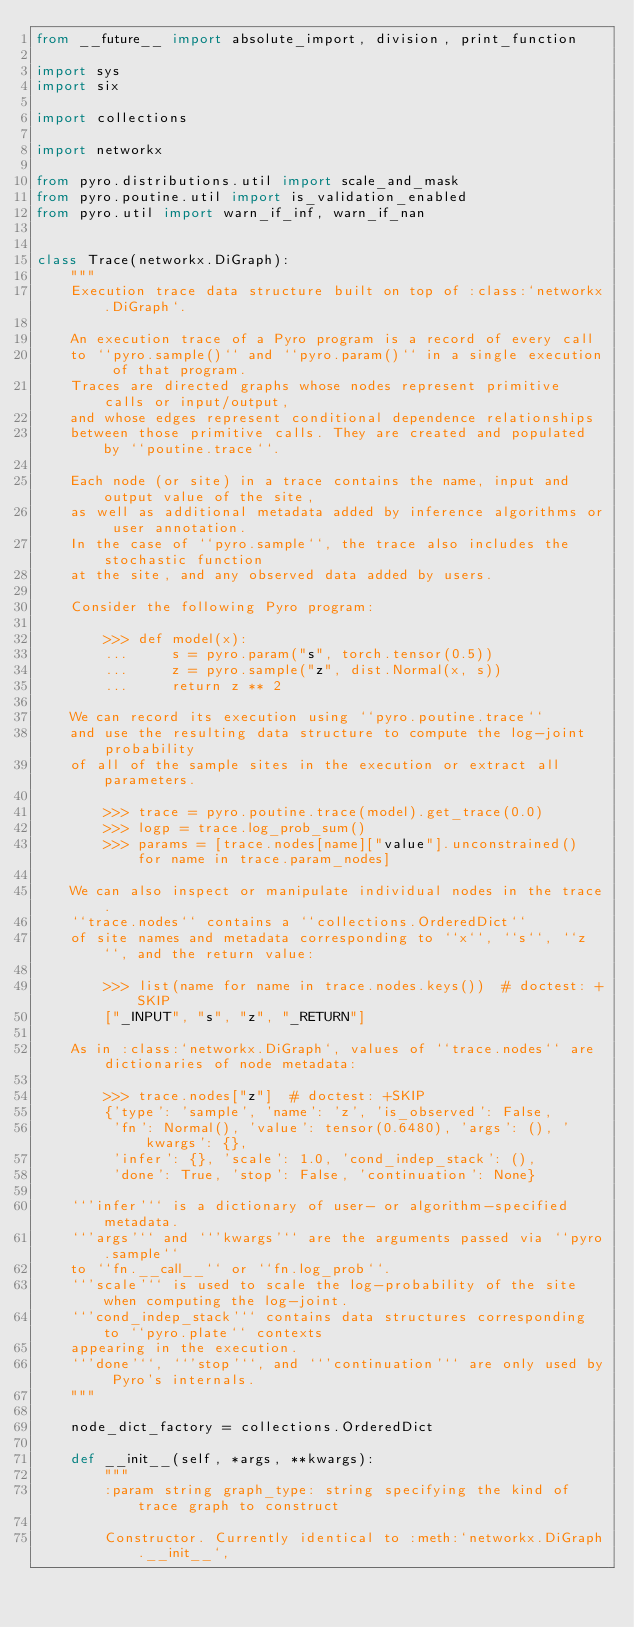Convert code to text. <code><loc_0><loc_0><loc_500><loc_500><_Python_>from __future__ import absolute_import, division, print_function

import sys
import six

import collections

import networkx

from pyro.distributions.util import scale_and_mask
from pyro.poutine.util import is_validation_enabled
from pyro.util import warn_if_inf, warn_if_nan


class Trace(networkx.DiGraph):
    """
    Execution trace data structure built on top of :class:`networkx.DiGraph`.

    An execution trace of a Pyro program is a record of every call
    to ``pyro.sample()`` and ``pyro.param()`` in a single execution of that program.
    Traces are directed graphs whose nodes represent primitive calls or input/output,
    and whose edges represent conditional dependence relationships
    between those primitive calls. They are created and populated by ``poutine.trace``.

    Each node (or site) in a trace contains the name, input and output value of the site,
    as well as additional metadata added by inference algorithms or user annotation.
    In the case of ``pyro.sample``, the trace also includes the stochastic function
    at the site, and any observed data added by users.

    Consider the following Pyro program:

        >>> def model(x):
        ...     s = pyro.param("s", torch.tensor(0.5))
        ...     z = pyro.sample("z", dist.Normal(x, s))
        ...     return z ** 2

    We can record its execution using ``pyro.poutine.trace``
    and use the resulting data structure to compute the log-joint probability
    of all of the sample sites in the execution or extract all parameters.

        >>> trace = pyro.poutine.trace(model).get_trace(0.0)
        >>> logp = trace.log_prob_sum()
        >>> params = [trace.nodes[name]["value"].unconstrained() for name in trace.param_nodes]

    We can also inspect or manipulate individual nodes in the trace.
    ``trace.nodes`` contains a ``collections.OrderedDict``
    of site names and metadata corresponding to ``x``, ``s``, ``z``, and the return value:

        >>> list(name for name in trace.nodes.keys())  # doctest: +SKIP
        ["_INPUT", "s", "z", "_RETURN"]

    As in :class:`networkx.DiGraph`, values of ``trace.nodes`` are dictionaries of node metadata:

        >>> trace.nodes["z"]  # doctest: +SKIP
        {'type': 'sample', 'name': 'z', 'is_observed': False,
         'fn': Normal(), 'value': tensor(0.6480), 'args': (), 'kwargs': {},
         'infer': {}, 'scale': 1.0, 'cond_indep_stack': (),
         'done': True, 'stop': False, 'continuation': None}

    ``'infer'`` is a dictionary of user- or algorithm-specified metadata.
    ``'args'`` and ``'kwargs'`` are the arguments passed via ``pyro.sample``
    to ``fn.__call__`` or ``fn.log_prob``.
    ``'scale'`` is used to scale the log-probability of the site when computing the log-joint.
    ``'cond_indep_stack'`` contains data structures corresponding to ``pyro.plate`` contexts
    appearing in the execution.
    ``'done'``, ``'stop'``, and ``'continuation'`` are only used by Pyro's internals.
    """

    node_dict_factory = collections.OrderedDict

    def __init__(self, *args, **kwargs):
        """
        :param string graph_type: string specifying the kind of trace graph to construct

        Constructor. Currently identical to :meth:`networkx.DiGraph.__init__`,</code> 